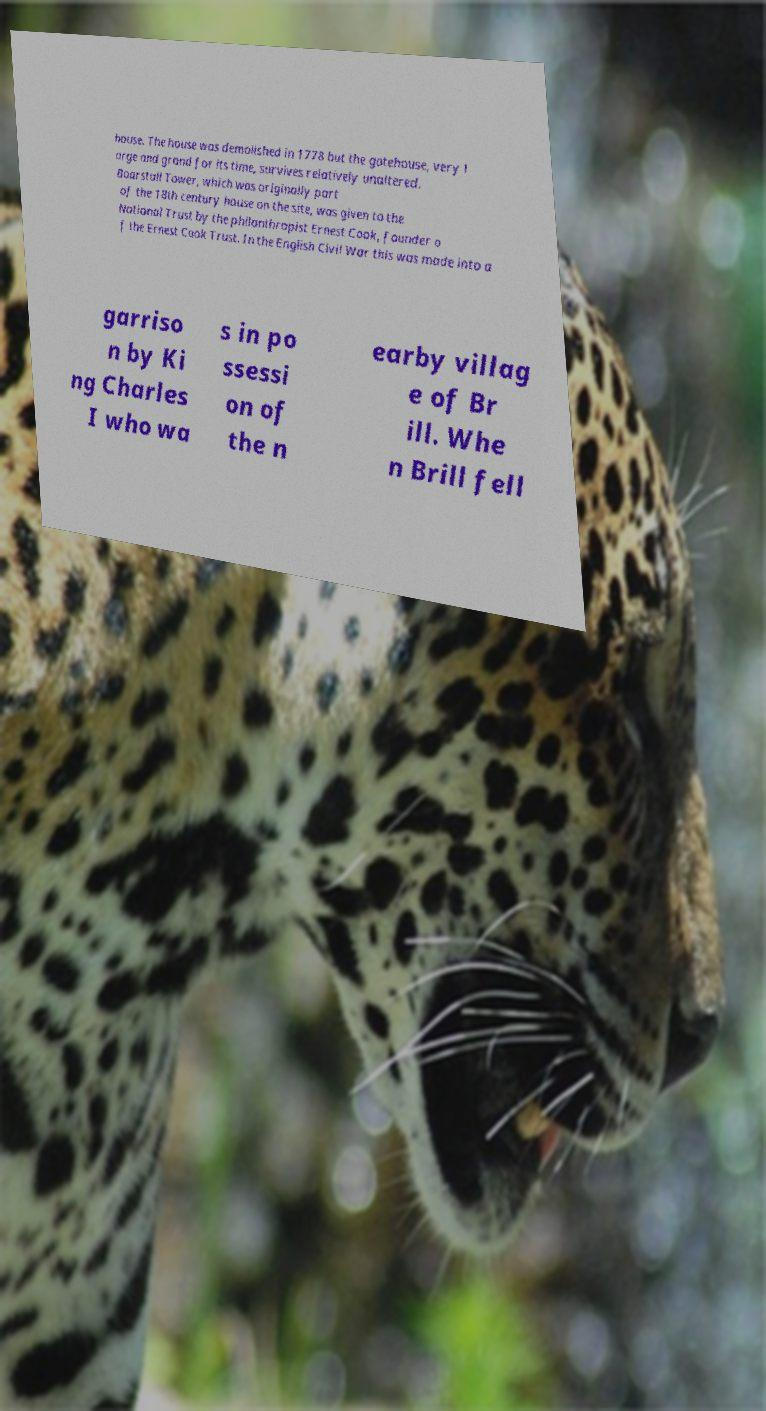Please identify and transcribe the text found in this image. house. The house was demolished in 1778 but the gatehouse, very l arge and grand for its time, survives relatively unaltered. Boarstall Tower, which was originally part of the 18th century house on the site, was given to the National Trust by the philanthropist Ernest Cook, founder o f the Ernest Cook Trust. In the English Civil War this was made into a garriso n by Ki ng Charles I who wa s in po ssessi on of the n earby villag e of Br ill. Whe n Brill fell 